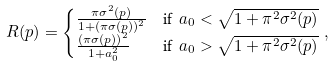<formula> <loc_0><loc_0><loc_500><loc_500>R ( p ) & = \begin{cases} \frac { \pi \sigma ^ { 2 } ( p ) } { 1 + ( \pi \sigma ( p ) ) ^ { 2 } } & \text {if } \ a _ { 0 } < \sqrt { 1 + \pi ^ { 2 } \sigma ^ { 2 } ( p ) } \\ \frac { \left ( \pi \sigma ( p ) \right ) ^ { 2 } } { 1 + a _ { 0 } ^ { 2 } } & \text {if } \ a _ { 0 } > \sqrt { 1 + \pi ^ { 2 } \sigma ^ { 2 } ( p ) } \end{cases} ,</formula> 